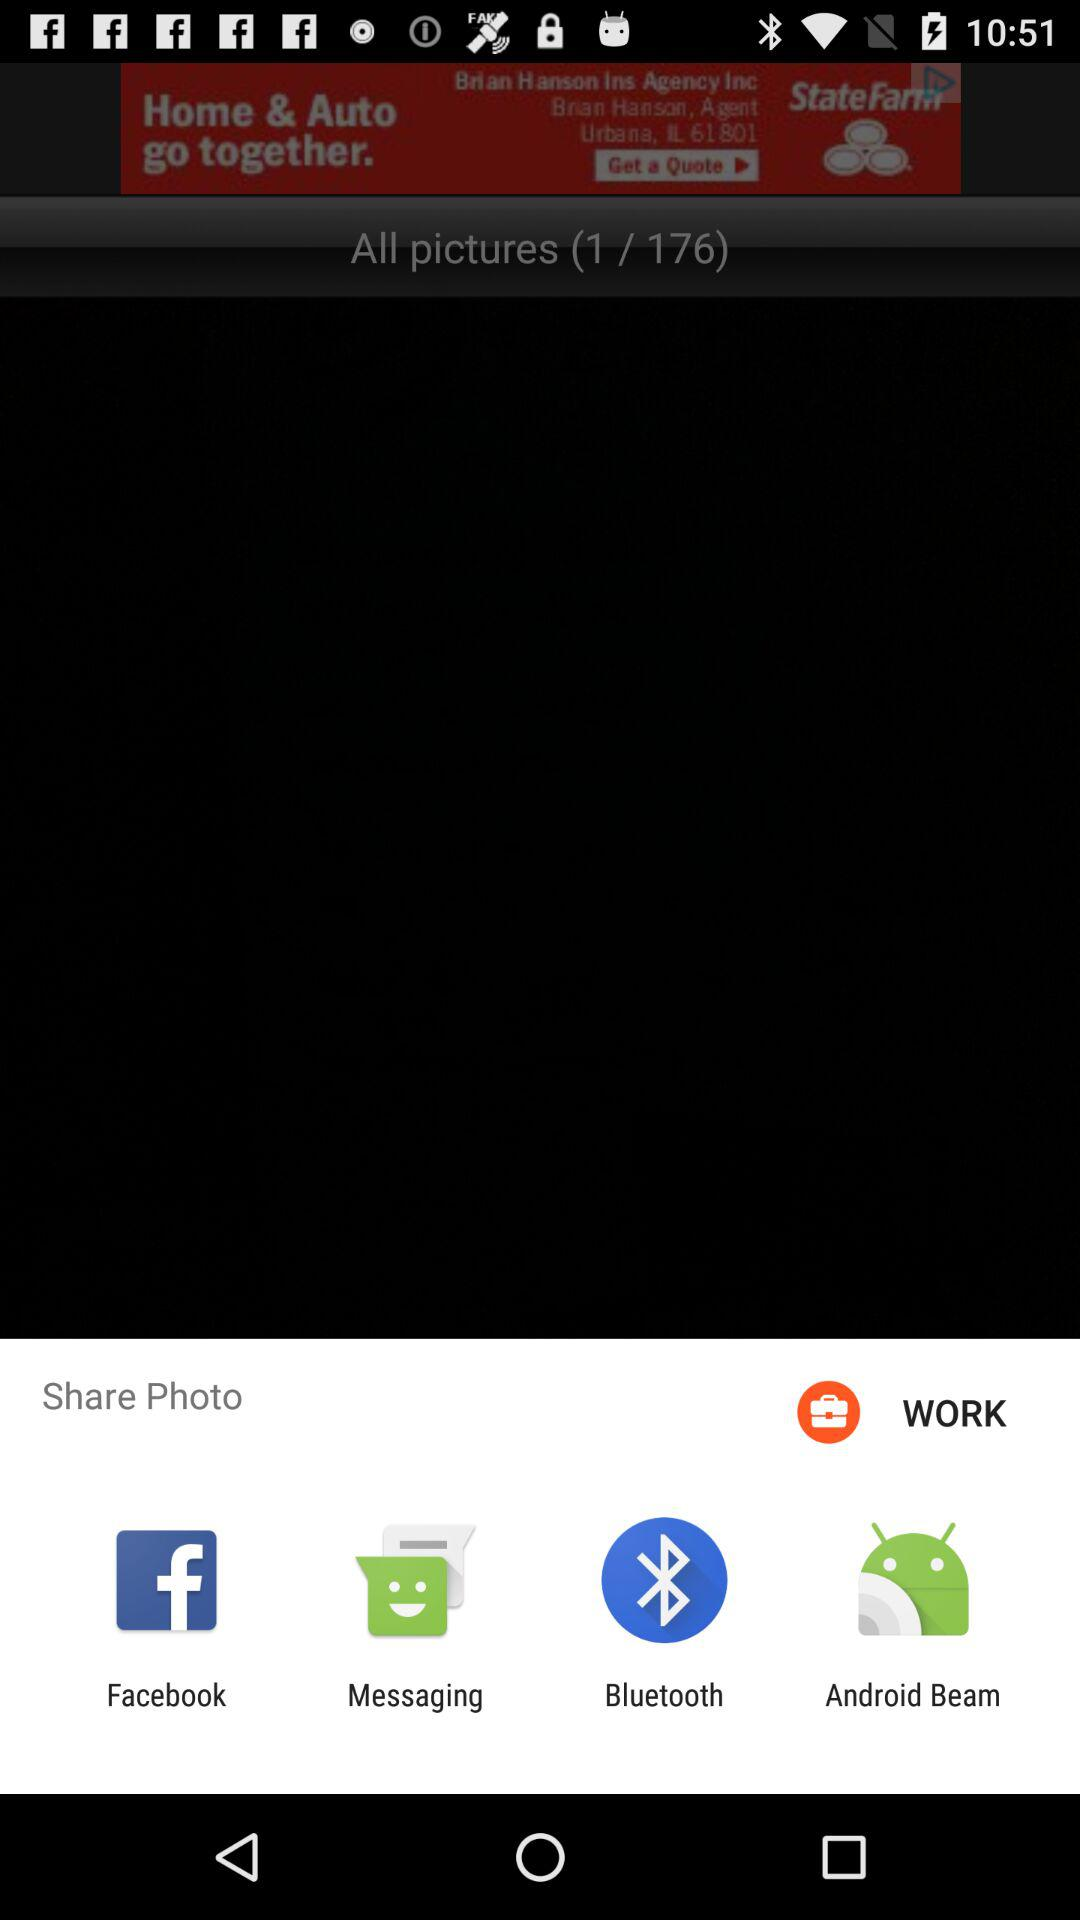Which applications can be used for sharing the photos? The applications that can be used are "Facebook", "Messaging", "Bluetooth" and "Android Beam". 